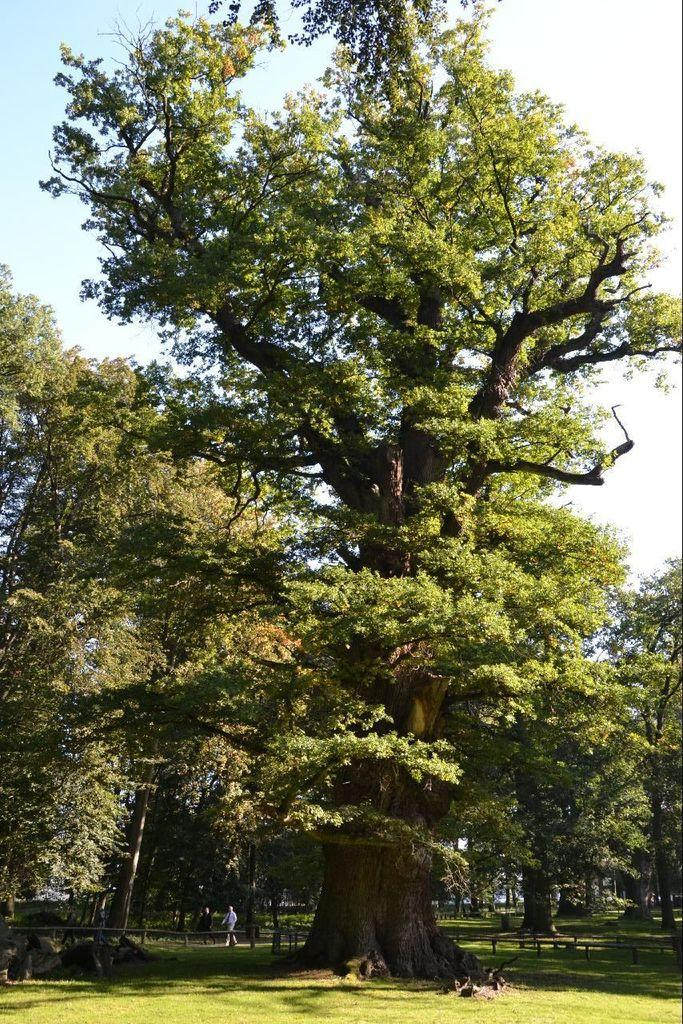What type of vegetation is present in the image? There are green color trees in the image. What type of barrier can be seen in the image? There is fencing in the image. What part of the natural environment is visible in the image? The sky is visible in the image. What is the person in the image doing? There is a person walking in the image. Can you see a bee using a comb to make music in the image? There is no bee or comb present in the image, nor is there any indication of music being made. 